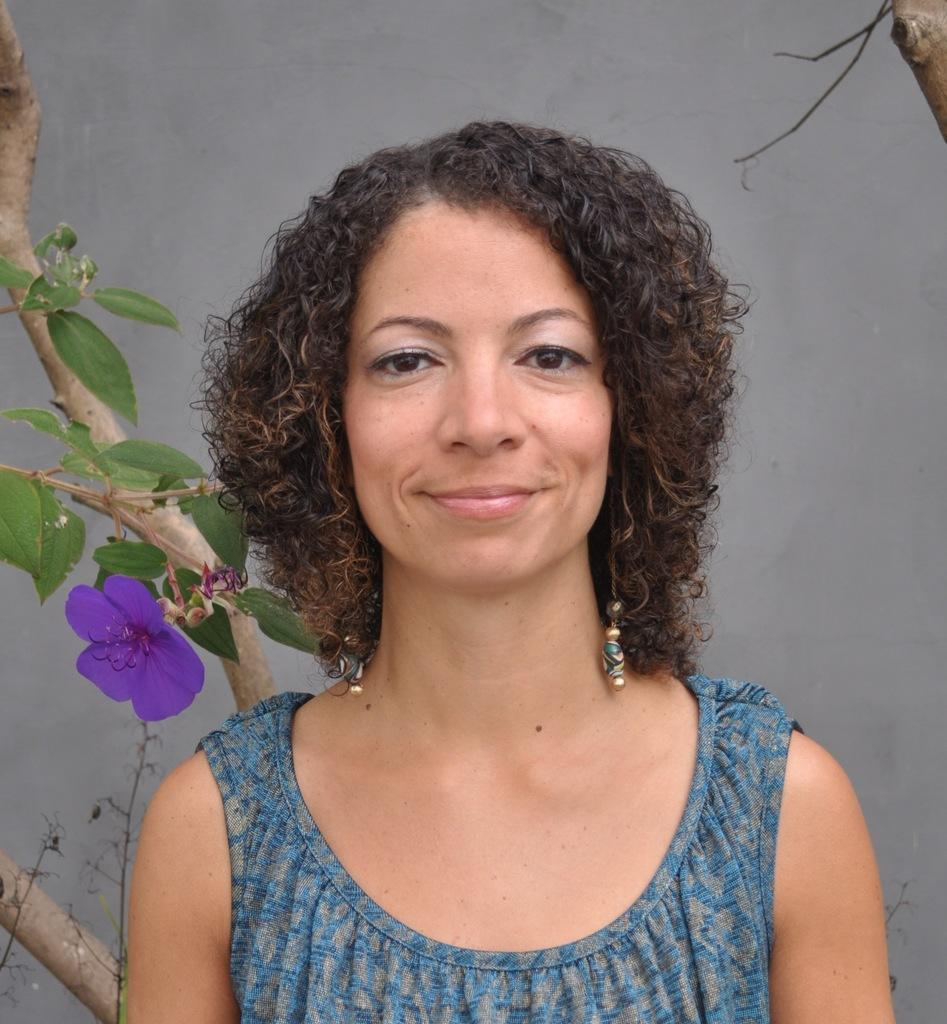Who is present in the image? There is a woman in the image. What is the woman doing in the image? The woman is smiling in the image. What type of plant can be seen in the image? There is a small tree with leaves and a flower in the image. What is visible in the background of the image? There is a wall in the background of the image. How many mice can be seen climbing the tree in the image? There are no mice present in the image; it features a woman smiling and a small tree with leaves and a flower. What type of net is used to catch the flower in the image? There is no net present in the image, and the flower is not being caught. 